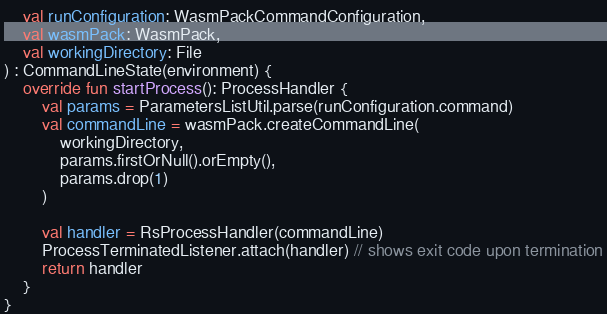<code> <loc_0><loc_0><loc_500><loc_500><_Kotlin_>    val runConfiguration: WasmPackCommandConfiguration,
    val wasmPack: WasmPack,
    val workingDirectory: File
) : CommandLineState(environment) {
    override fun startProcess(): ProcessHandler {
        val params = ParametersListUtil.parse(runConfiguration.command)
        val commandLine = wasmPack.createCommandLine(
            workingDirectory,
            params.firstOrNull().orEmpty(),
            params.drop(1)
        )

        val handler = RsProcessHandler(commandLine)
        ProcessTerminatedListener.attach(handler) // shows exit code upon termination
        return handler
    }
}
</code> 